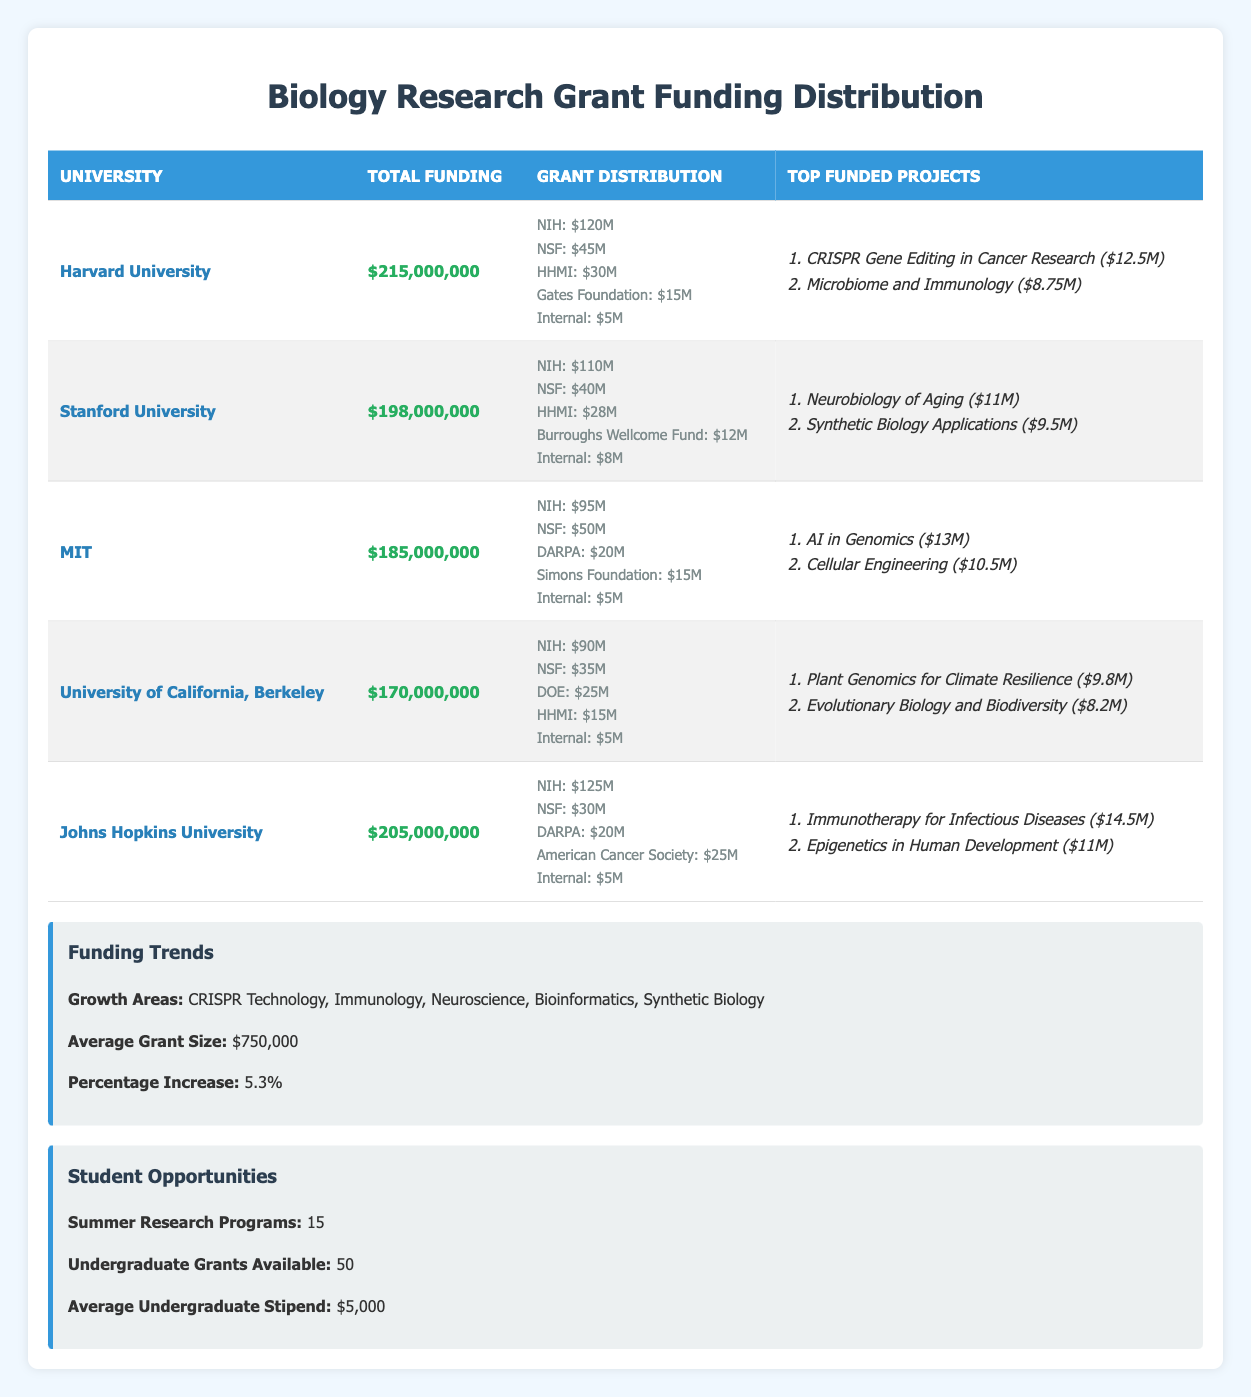What is the total funding for John Hopkins University? Looking at the table, the total funding for Johns Hopkins University is listed as $205,000,000 in the corresponding row.
Answer: $205,000,000 Which university received the highest funding from the NIH? According to the table, Johns Hopkins University received $125,000,000 from the NIH, which is the highest amount compared to the other universities listed.
Answer: Johns Hopkins University What is the sum of total funding for Harvard University and MIT? Harvard University has total funding of $215,000,000 and MIT has total funding of $185,000,000. We calculate the sum: $215,000,000 + $185,000,000 = $400,000,000.
Answer: $400,000,000 Is the top project for Stanford University focused on neuroscience? The top project listed for Stanford University is "Neurobiology of Aging," which falls under the broader category of neuroscience, confirming that it is indeed focused on neuroscience.
Answer: Yes What is the average funding amount from the NSF across all universities? To find the average funding from the NSF, we first need to sum the NSF amounts: $45,000,000 (Harvard) + $40,000,000 (Stanford) + $50,000,000 (MIT) + $35,000,000 (UC Berkeley) + $30,000,000 (Johns Hopkins) = $200,000,000. There are 5 universities, so we divide: $200,000,000 / 5 = $40,000,000.
Answer: $40,000,000 How much funding did the Gates Foundation provide to Harvard University? From the table, it is indicated that the Gates Foundation provided $15,000,000 to Harvard University.
Answer: $15,000,000 Which grant source contributed the least to total funding across all universities? By reviewing the rows in the table, the Internal funding source contributed $5,000,000 to each university, making it the smallest grant source compared to others such as NIH and NSF.
Answer: Internal What is the combined funding from DARPA for MIT and Johns Hopkins University? For MIT, DARPA provided $20,000,000, while for Johns Hopkins University, the contribution from DARPA is also $20,000,000. The combined funding is: $20,000,000 + $20,000,000 = $40,000,000.
Answer: $40,000,000 Which university ranks second in total funding? Based on the funding amounts presented, after Harvard University ($215,000,000), Johns Hopkins University ranks second with $205,000,000 total funding.
Answer: Johns Hopkins University 